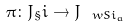Convert formula to latex. <formula><loc_0><loc_0><loc_500><loc_500>\pi \colon J _ { \S } i \to J _ { \ w S i _ { a } }</formula> 